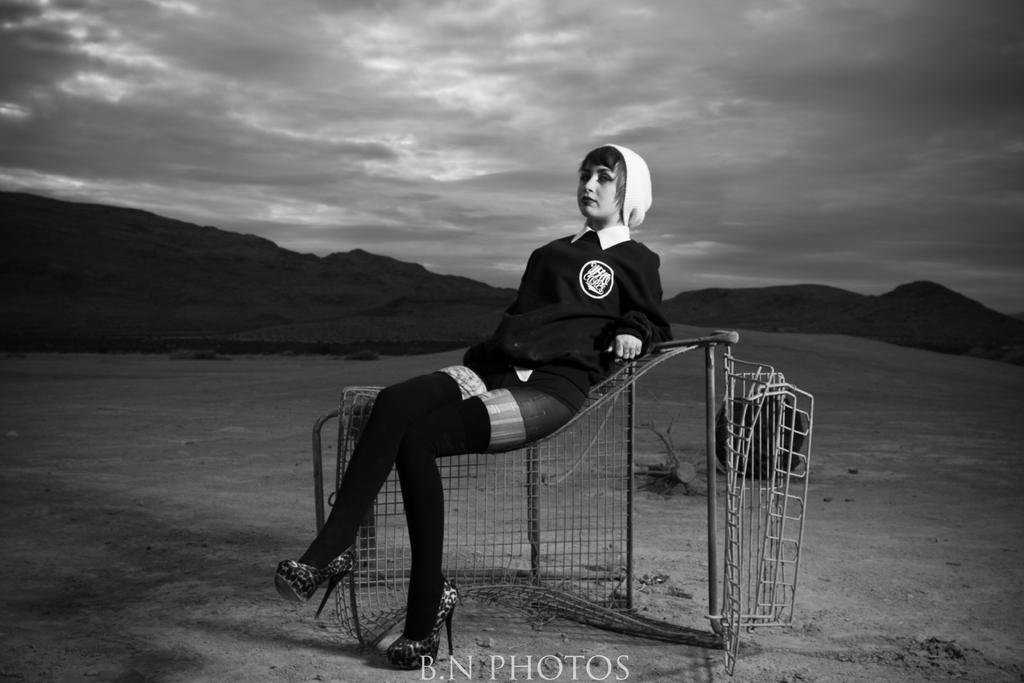What object can be seen in the image that is used for catching or holding things? There is a net in the image. Who is present in the image? There is a woman in the image. What is the woman wearing? The woman is wearing a black dress. What is the woman doing in the image? The woman is sitting. What can be seen in the background of the image? There are hills in the background of the image. What is visible at the top of the image? The sky is visible at the top of the image. What can be observed in the sky? Clouds are present in the sky. What type of box can be seen in the image? There is no box present in the image. What action is the woman performing in the image? The woman is sitting, but we cannot determine any specific action she is performing. 